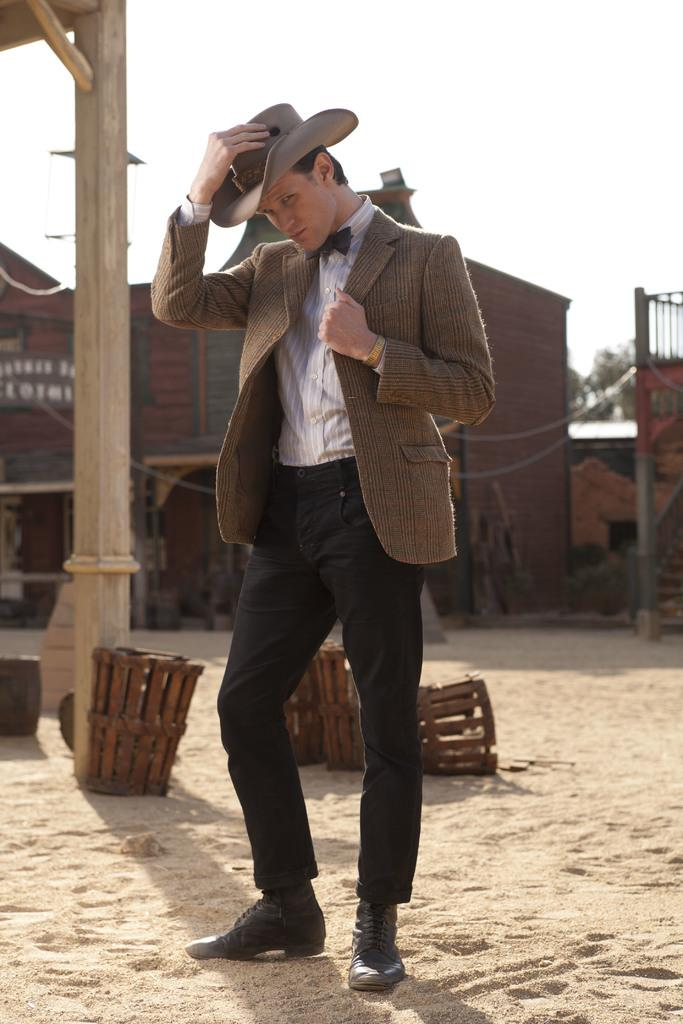What type of structure is present in the image? There is a house in the image. Can you describe the person in the image? A man is standing in the image. What else can be seen in the image besides the house and the man? There are many objects in the image. What is visible in the background of the image? There is a sky visible in the image. What type of wool is being used to create the historical ornament in the image? There is no wool, history, or ornament present in the image. 